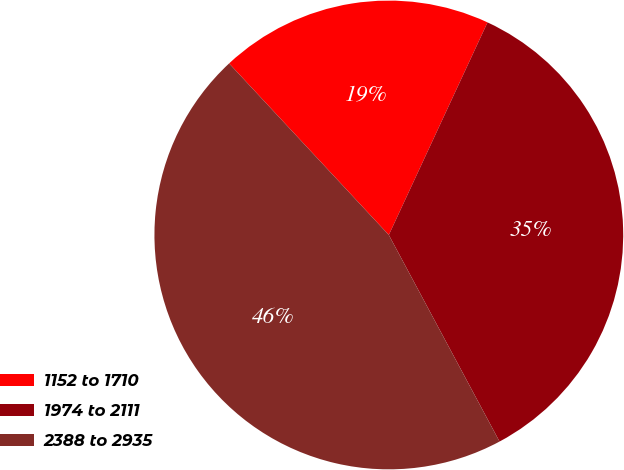Convert chart. <chart><loc_0><loc_0><loc_500><loc_500><pie_chart><fcel>1152 to 1710<fcel>1974 to 2111<fcel>2388 to 2935<nl><fcel>18.85%<fcel>35.25%<fcel>45.9%<nl></chart> 